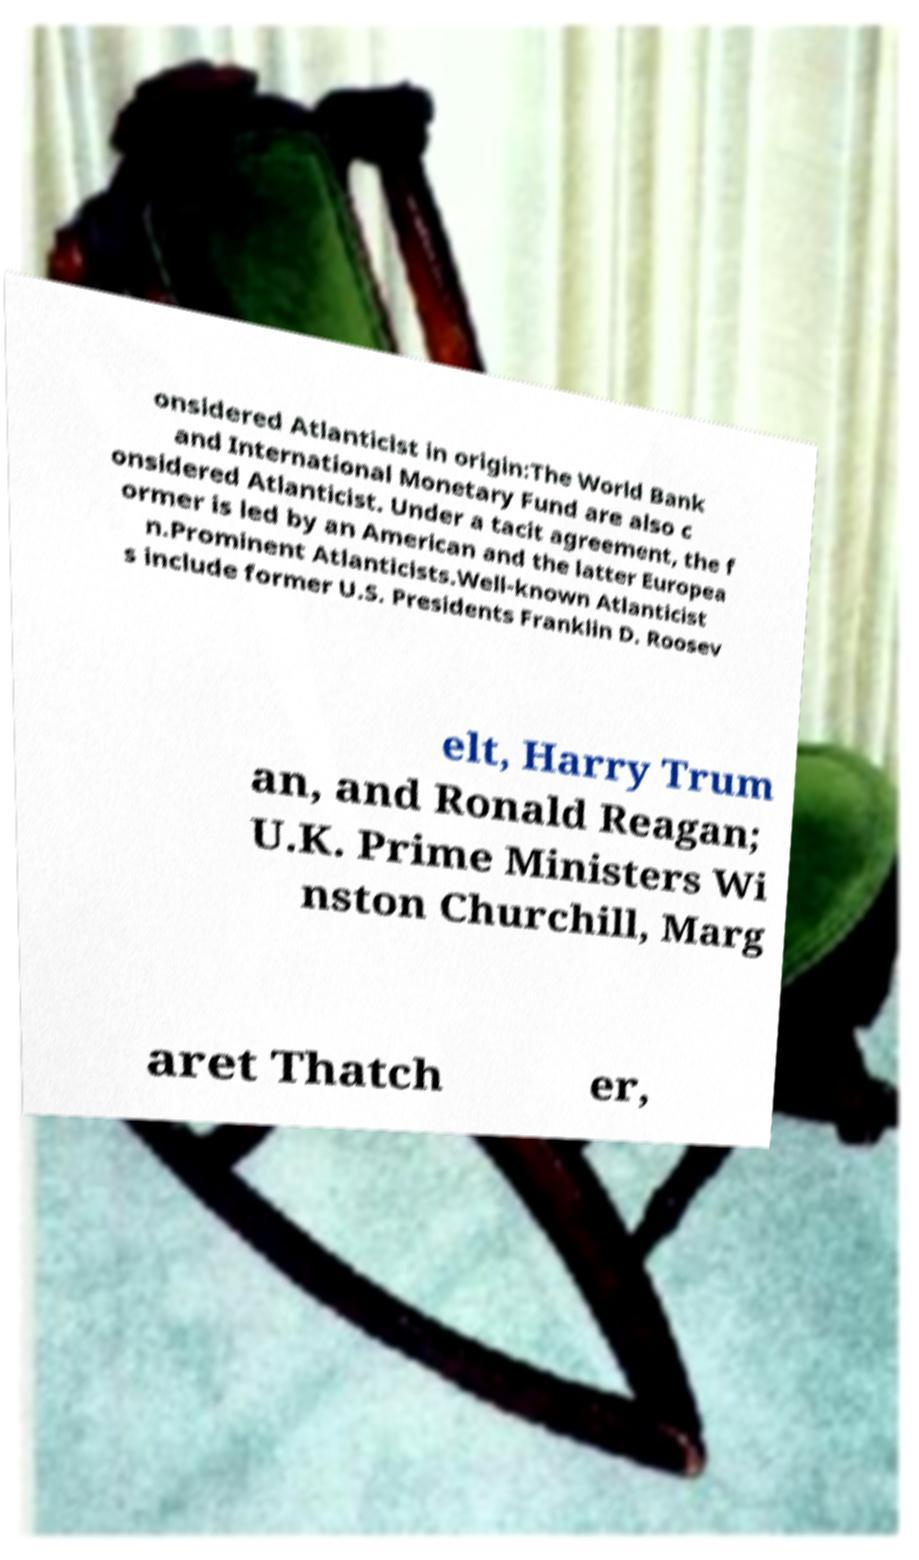Can you accurately transcribe the text from the provided image for me? onsidered Atlanticist in origin:The World Bank and International Monetary Fund are also c onsidered Atlanticist. Under a tacit agreement, the f ormer is led by an American and the latter Europea n.Prominent Atlanticists.Well-known Atlanticist s include former U.S. Presidents Franklin D. Roosev elt, Harry Trum an, and Ronald Reagan; U.K. Prime Ministers Wi nston Churchill, Marg aret Thatch er, 